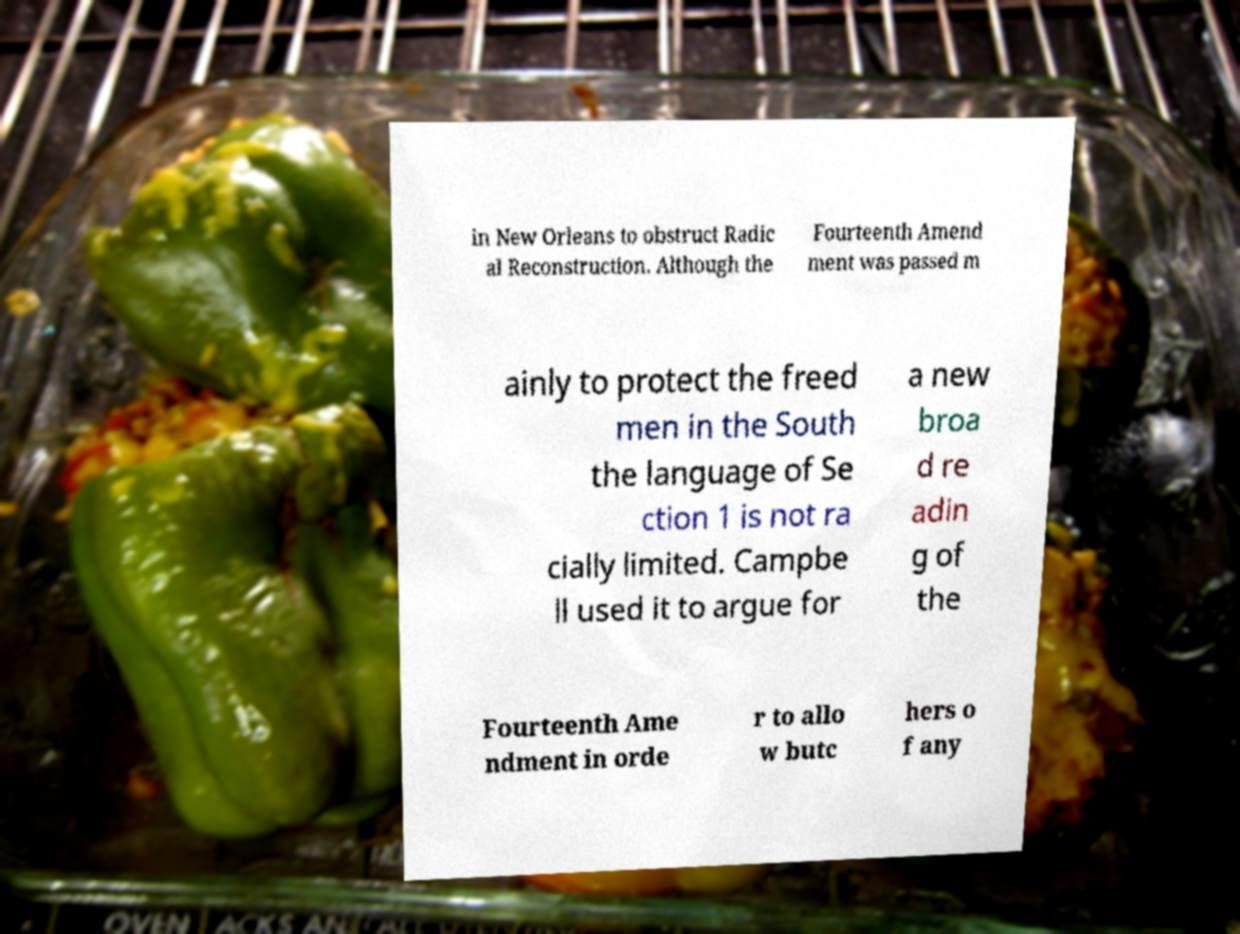I need the written content from this picture converted into text. Can you do that? in New Orleans to obstruct Radic al Reconstruction. Although the Fourteenth Amend ment was passed m ainly to protect the freed men in the South the language of Se ction 1 is not ra cially limited. Campbe ll used it to argue for a new broa d re adin g of the Fourteenth Ame ndment in orde r to allo w butc hers o f any 